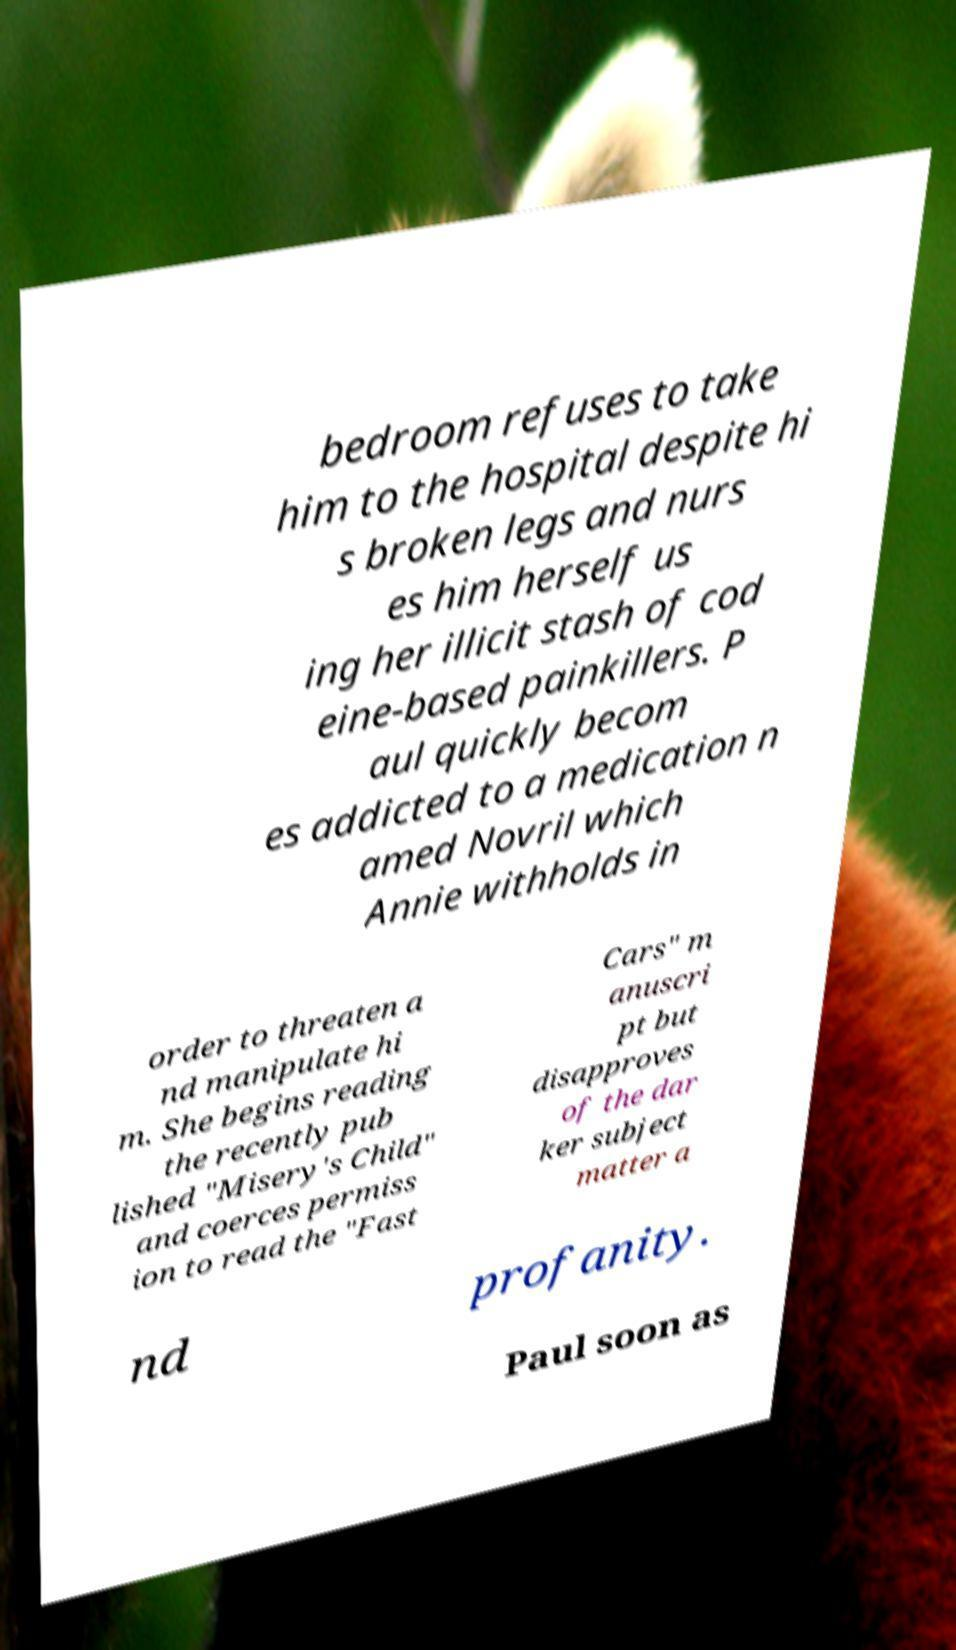Could you extract and type out the text from this image? bedroom refuses to take him to the hospital despite hi s broken legs and nurs es him herself us ing her illicit stash of cod eine-based painkillers. P aul quickly becom es addicted to a medication n amed Novril which Annie withholds in order to threaten a nd manipulate hi m. She begins reading the recently pub lished "Misery's Child" and coerces permiss ion to read the "Fast Cars" m anuscri pt but disapproves of the dar ker subject matter a nd profanity. Paul soon as 